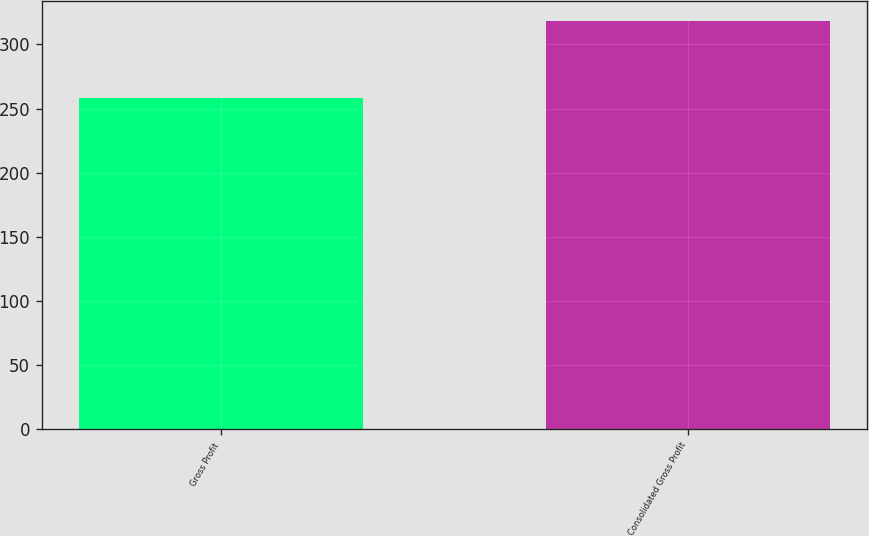Convert chart. <chart><loc_0><loc_0><loc_500><loc_500><bar_chart><fcel>Gross Profit<fcel>Consolidated Gross Profit<nl><fcel>258<fcel>318.1<nl></chart> 